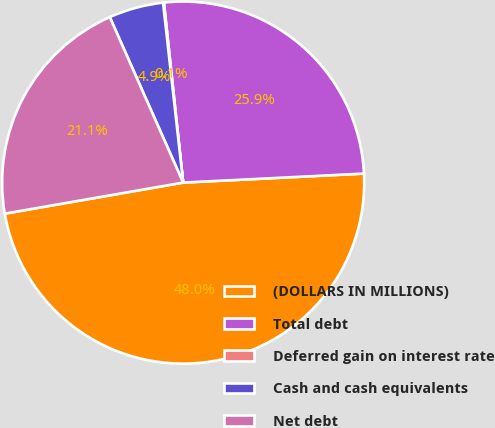<chart> <loc_0><loc_0><loc_500><loc_500><pie_chart><fcel>(DOLLARS IN MILLIONS)<fcel>Total debt<fcel>Deferred gain on interest rate<fcel>Cash and cash equivalents<fcel>Net debt<nl><fcel>48.05%<fcel>25.9%<fcel>0.08%<fcel>4.87%<fcel>21.1%<nl></chart> 